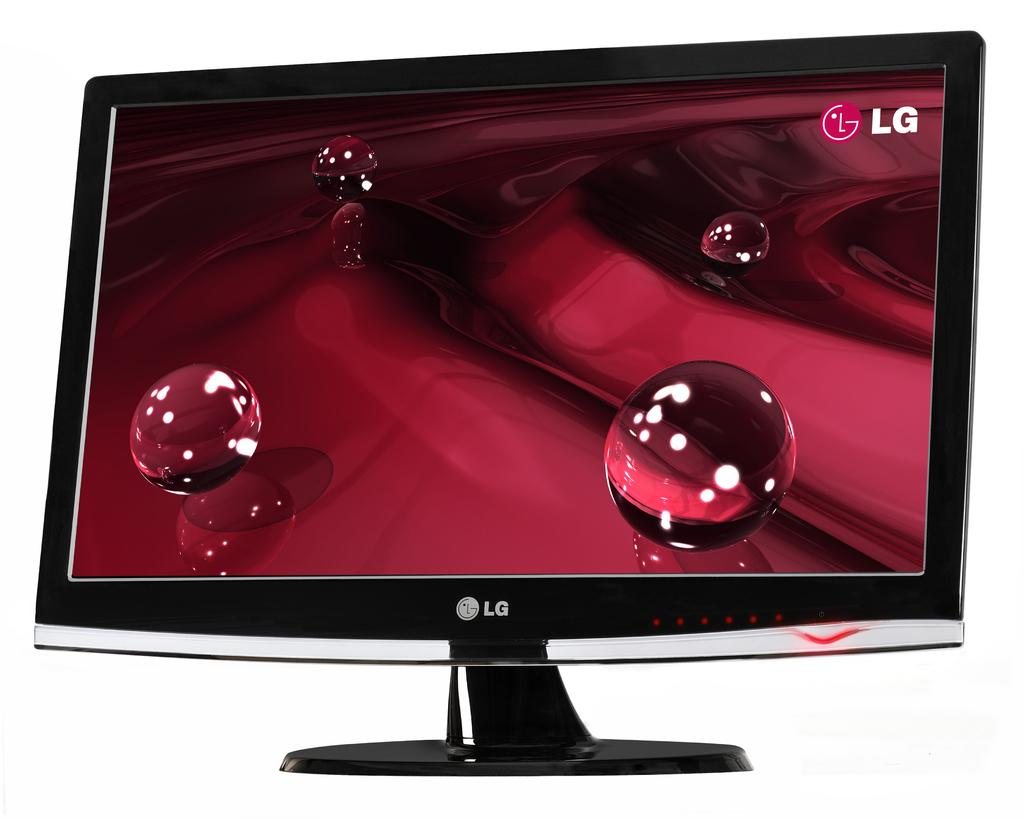<image>
Give a short and clear explanation of the subsequent image. An LG monitor with a red background and balls on it. 